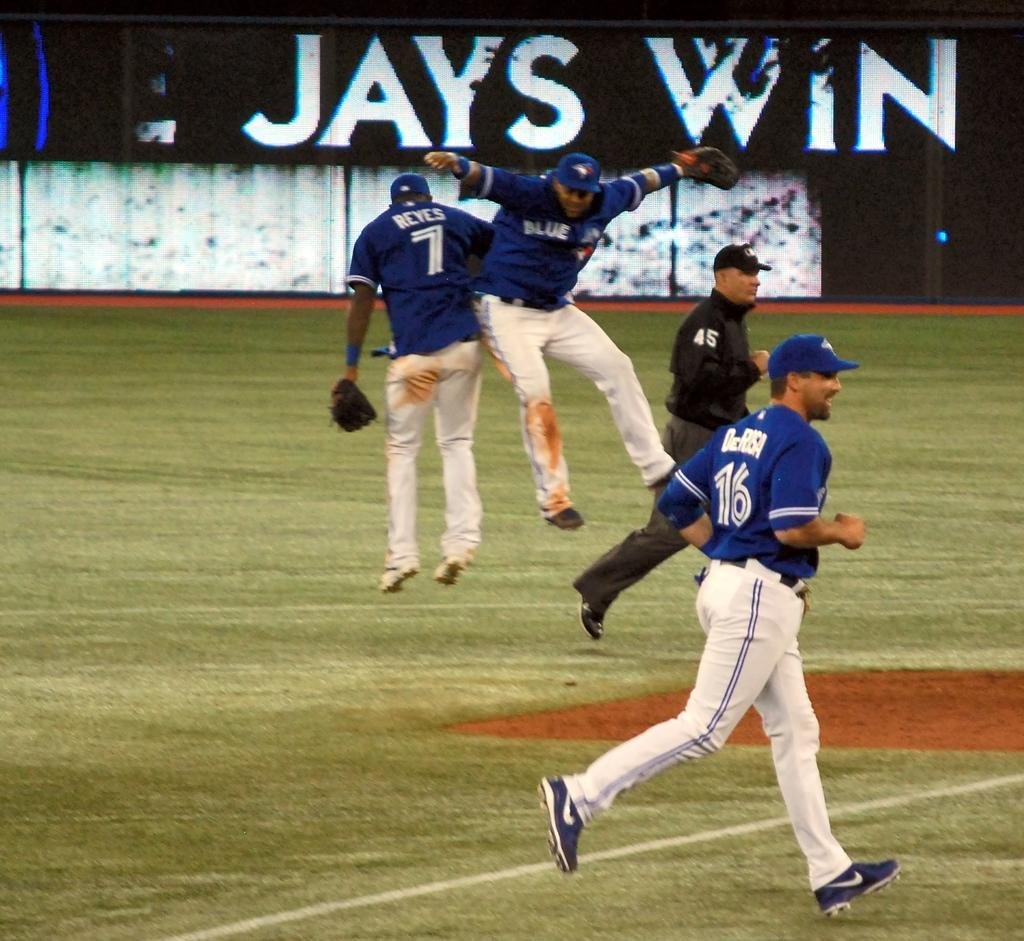Provide a one-sentence caption for the provided image. Blue Jays team members showing excitement on the field with a sign behind them in the background that says JAYS WIN. 